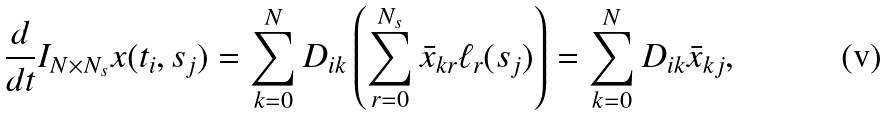Convert formula to latex. <formula><loc_0><loc_0><loc_500><loc_500>\frac { d } { d t } I _ { N \times N _ { s } } x ( t _ { i } , s _ { j } ) & = \sum _ { k = 0 } ^ { N } D _ { i k } \left ( \sum _ { r = 0 } ^ { N _ { s } } \bar { x } _ { k r } \ell _ { r } ( s _ { j } ) \right ) = \sum _ { k = 0 } ^ { N } D _ { i k } \bar { x } _ { k j } ,</formula> 